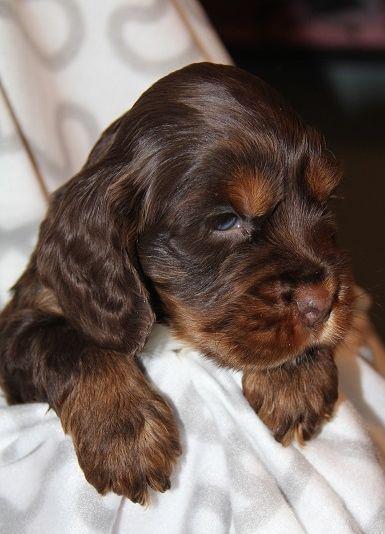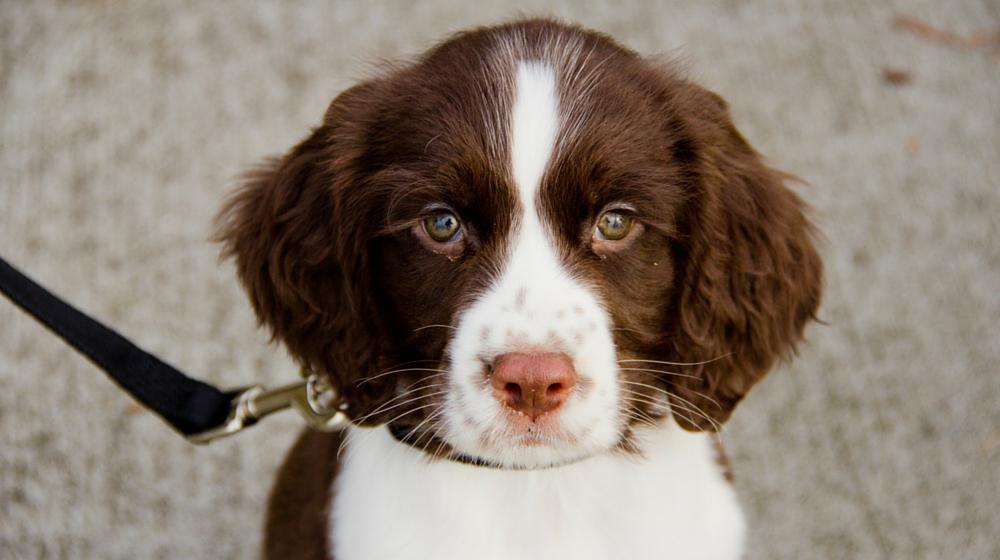The first image is the image on the left, the second image is the image on the right. For the images displayed, is the sentence "One dog is brown and white" factually correct? Answer yes or no. Yes. 